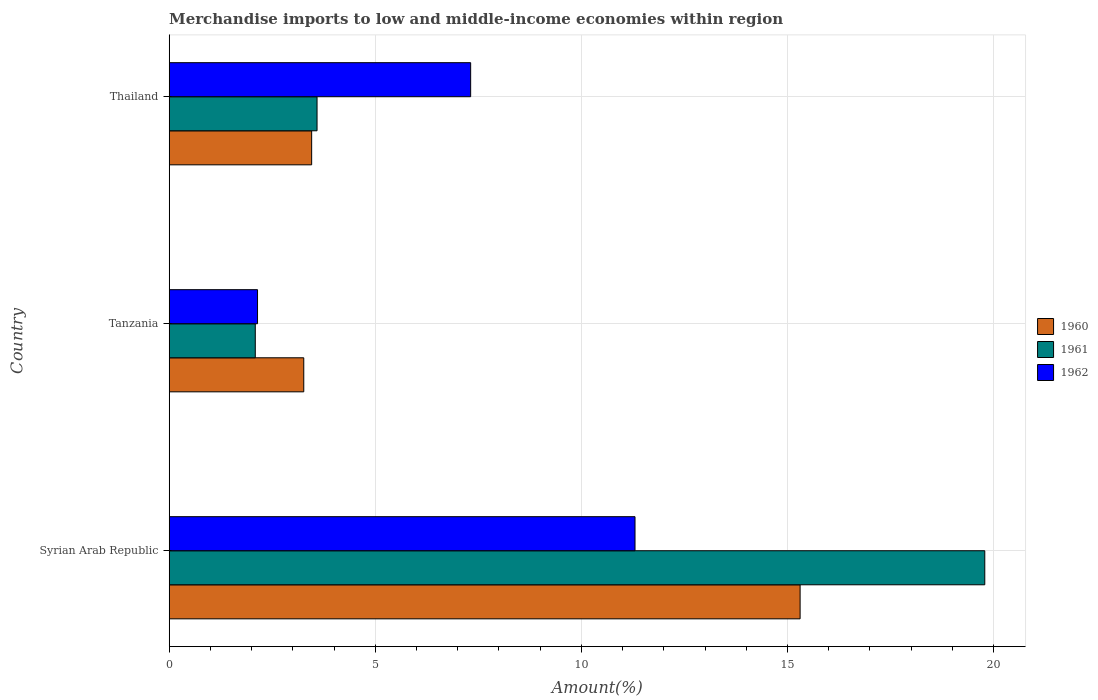How many different coloured bars are there?
Make the answer very short. 3. What is the label of the 2nd group of bars from the top?
Offer a terse response. Tanzania. What is the percentage of amount earned from merchandise imports in 1961 in Syrian Arab Republic?
Your answer should be very brief. 19.79. Across all countries, what is the maximum percentage of amount earned from merchandise imports in 1960?
Your answer should be very brief. 15.31. Across all countries, what is the minimum percentage of amount earned from merchandise imports in 1961?
Provide a short and direct response. 2.09. In which country was the percentage of amount earned from merchandise imports in 1960 maximum?
Give a very brief answer. Syrian Arab Republic. In which country was the percentage of amount earned from merchandise imports in 1961 minimum?
Your response must be concise. Tanzania. What is the total percentage of amount earned from merchandise imports in 1962 in the graph?
Offer a terse response. 20.76. What is the difference between the percentage of amount earned from merchandise imports in 1962 in Tanzania and that in Thailand?
Keep it short and to the point. -5.17. What is the difference between the percentage of amount earned from merchandise imports in 1962 in Tanzania and the percentage of amount earned from merchandise imports in 1960 in Syrian Arab Republic?
Provide a succinct answer. -13.16. What is the average percentage of amount earned from merchandise imports in 1960 per country?
Ensure brevity in your answer.  7.34. What is the difference between the percentage of amount earned from merchandise imports in 1961 and percentage of amount earned from merchandise imports in 1962 in Thailand?
Provide a succinct answer. -3.73. In how many countries, is the percentage of amount earned from merchandise imports in 1960 greater than 18 %?
Provide a succinct answer. 0. What is the ratio of the percentage of amount earned from merchandise imports in 1961 in Tanzania to that in Thailand?
Make the answer very short. 0.58. Is the difference between the percentage of amount earned from merchandise imports in 1961 in Syrian Arab Republic and Tanzania greater than the difference between the percentage of amount earned from merchandise imports in 1962 in Syrian Arab Republic and Tanzania?
Give a very brief answer. Yes. What is the difference between the highest and the second highest percentage of amount earned from merchandise imports in 1962?
Provide a short and direct response. 3.99. What is the difference between the highest and the lowest percentage of amount earned from merchandise imports in 1961?
Provide a short and direct response. 17.7. Is the sum of the percentage of amount earned from merchandise imports in 1961 in Syrian Arab Republic and Thailand greater than the maximum percentage of amount earned from merchandise imports in 1962 across all countries?
Keep it short and to the point. Yes. What does the 2nd bar from the top in Tanzania represents?
Offer a very short reply. 1961. What does the 3rd bar from the bottom in Syrian Arab Republic represents?
Your response must be concise. 1962. How many bars are there?
Your answer should be compact. 9. Are all the bars in the graph horizontal?
Your response must be concise. Yes. Are the values on the major ticks of X-axis written in scientific E-notation?
Make the answer very short. No. Where does the legend appear in the graph?
Your answer should be very brief. Center right. How are the legend labels stacked?
Offer a terse response. Vertical. What is the title of the graph?
Your answer should be very brief. Merchandise imports to low and middle-income economies within region. What is the label or title of the X-axis?
Offer a very short reply. Amount(%). What is the Amount(%) of 1960 in Syrian Arab Republic?
Provide a short and direct response. 15.31. What is the Amount(%) in 1961 in Syrian Arab Republic?
Provide a succinct answer. 19.79. What is the Amount(%) in 1962 in Syrian Arab Republic?
Provide a short and direct response. 11.3. What is the Amount(%) of 1960 in Tanzania?
Your answer should be compact. 3.26. What is the Amount(%) in 1961 in Tanzania?
Provide a short and direct response. 2.09. What is the Amount(%) of 1962 in Tanzania?
Ensure brevity in your answer.  2.14. What is the Amount(%) of 1960 in Thailand?
Offer a very short reply. 3.46. What is the Amount(%) in 1961 in Thailand?
Provide a succinct answer. 3.59. What is the Amount(%) in 1962 in Thailand?
Offer a terse response. 7.31. Across all countries, what is the maximum Amount(%) in 1960?
Make the answer very short. 15.31. Across all countries, what is the maximum Amount(%) in 1961?
Offer a very short reply. 19.79. Across all countries, what is the maximum Amount(%) in 1962?
Your answer should be very brief. 11.3. Across all countries, what is the minimum Amount(%) in 1960?
Offer a terse response. 3.26. Across all countries, what is the minimum Amount(%) in 1961?
Ensure brevity in your answer.  2.09. Across all countries, what is the minimum Amount(%) in 1962?
Ensure brevity in your answer.  2.14. What is the total Amount(%) of 1960 in the graph?
Your answer should be compact. 22.03. What is the total Amount(%) in 1961 in the graph?
Keep it short and to the point. 25.46. What is the total Amount(%) in 1962 in the graph?
Provide a short and direct response. 20.76. What is the difference between the Amount(%) in 1960 in Syrian Arab Republic and that in Tanzania?
Offer a very short reply. 12.04. What is the difference between the Amount(%) in 1961 in Syrian Arab Republic and that in Tanzania?
Your answer should be very brief. 17.7. What is the difference between the Amount(%) of 1962 in Syrian Arab Republic and that in Tanzania?
Make the answer very short. 9.16. What is the difference between the Amount(%) of 1960 in Syrian Arab Republic and that in Thailand?
Your answer should be very brief. 11.85. What is the difference between the Amount(%) of 1961 in Syrian Arab Republic and that in Thailand?
Your answer should be very brief. 16.2. What is the difference between the Amount(%) of 1962 in Syrian Arab Republic and that in Thailand?
Give a very brief answer. 3.99. What is the difference between the Amount(%) of 1960 in Tanzania and that in Thailand?
Provide a short and direct response. -0.19. What is the difference between the Amount(%) in 1961 in Tanzania and that in Thailand?
Provide a short and direct response. -1.5. What is the difference between the Amount(%) of 1962 in Tanzania and that in Thailand?
Ensure brevity in your answer.  -5.17. What is the difference between the Amount(%) of 1960 in Syrian Arab Republic and the Amount(%) of 1961 in Tanzania?
Keep it short and to the point. 13.22. What is the difference between the Amount(%) of 1960 in Syrian Arab Republic and the Amount(%) of 1962 in Tanzania?
Ensure brevity in your answer.  13.16. What is the difference between the Amount(%) of 1961 in Syrian Arab Republic and the Amount(%) of 1962 in Tanzania?
Your answer should be very brief. 17.64. What is the difference between the Amount(%) in 1960 in Syrian Arab Republic and the Amount(%) in 1961 in Thailand?
Your answer should be compact. 11.72. What is the difference between the Amount(%) in 1960 in Syrian Arab Republic and the Amount(%) in 1962 in Thailand?
Ensure brevity in your answer.  7.99. What is the difference between the Amount(%) in 1961 in Syrian Arab Republic and the Amount(%) in 1962 in Thailand?
Your answer should be compact. 12.47. What is the difference between the Amount(%) of 1960 in Tanzania and the Amount(%) of 1961 in Thailand?
Provide a succinct answer. -0.32. What is the difference between the Amount(%) of 1960 in Tanzania and the Amount(%) of 1962 in Thailand?
Your answer should be compact. -4.05. What is the difference between the Amount(%) of 1961 in Tanzania and the Amount(%) of 1962 in Thailand?
Your answer should be compact. -5.23. What is the average Amount(%) of 1960 per country?
Provide a succinct answer. 7.34. What is the average Amount(%) of 1961 per country?
Keep it short and to the point. 8.49. What is the average Amount(%) in 1962 per country?
Your answer should be very brief. 6.92. What is the difference between the Amount(%) of 1960 and Amount(%) of 1961 in Syrian Arab Republic?
Your response must be concise. -4.48. What is the difference between the Amount(%) in 1960 and Amount(%) in 1962 in Syrian Arab Republic?
Ensure brevity in your answer.  4.01. What is the difference between the Amount(%) of 1961 and Amount(%) of 1962 in Syrian Arab Republic?
Make the answer very short. 8.49. What is the difference between the Amount(%) in 1960 and Amount(%) in 1961 in Tanzania?
Ensure brevity in your answer.  1.18. What is the difference between the Amount(%) in 1960 and Amount(%) in 1962 in Tanzania?
Make the answer very short. 1.12. What is the difference between the Amount(%) in 1961 and Amount(%) in 1962 in Tanzania?
Your response must be concise. -0.05. What is the difference between the Amount(%) in 1960 and Amount(%) in 1961 in Thailand?
Give a very brief answer. -0.13. What is the difference between the Amount(%) of 1960 and Amount(%) of 1962 in Thailand?
Offer a terse response. -3.86. What is the difference between the Amount(%) of 1961 and Amount(%) of 1962 in Thailand?
Your answer should be very brief. -3.73. What is the ratio of the Amount(%) of 1960 in Syrian Arab Republic to that in Tanzania?
Offer a very short reply. 4.69. What is the ratio of the Amount(%) of 1961 in Syrian Arab Republic to that in Tanzania?
Your answer should be compact. 9.48. What is the ratio of the Amount(%) in 1962 in Syrian Arab Republic to that in Tanzania?
Keep it short and to the point. 5.27. What is the ratio of the Amount(%) in 1960 in Syrian Arab Republic to that in Thailand?
Give a very brief answer. 4.43. What is the ratio of the Amount(%) of 1961 in Syrian Arab Republic to that in Thailand?
Your answer should be compact. 5.52. What is the ratio of the Amount(%) in 1962 in Syrian Arab Republic to that in Thailand?
Offer a very short reply. 1.55. What is the ratio of the Amount(%) of 1960 in Tanzania to that in Thailand?
Keep it short and to the point. 0.94. What is the ratio of the Amount(%) in 1961 in Tanzania to that in Thailand?
Your answer should be compact. 0.58. What is the ratio of the Amount(%) of 1962 in Tanzania to that in Thailand?
Provide a succinct answer. 0.29. What is the difference between the highest and the second highest Amount(%) of 1960?
Offer a very short reply. 11.85. What is the difference between the highest and the second highest Amount(%) in 1961?
Your answer should be compact. 16.2. What is the difference between the highest and the second highest Amount(%) in 1962?
Your response must be concise. 3.99. What is the difference between the highest and the lowest Amount(%) of 1960?
Offer a very short reply. 12.04. What is the difference between the highest and the lowest Amount(%) in 1961?
Provide a succinct answer. 17.7. What is the difference between the highest and the lowest Amount(%) in 1962?
Keep it short and to the point. 9.16. 